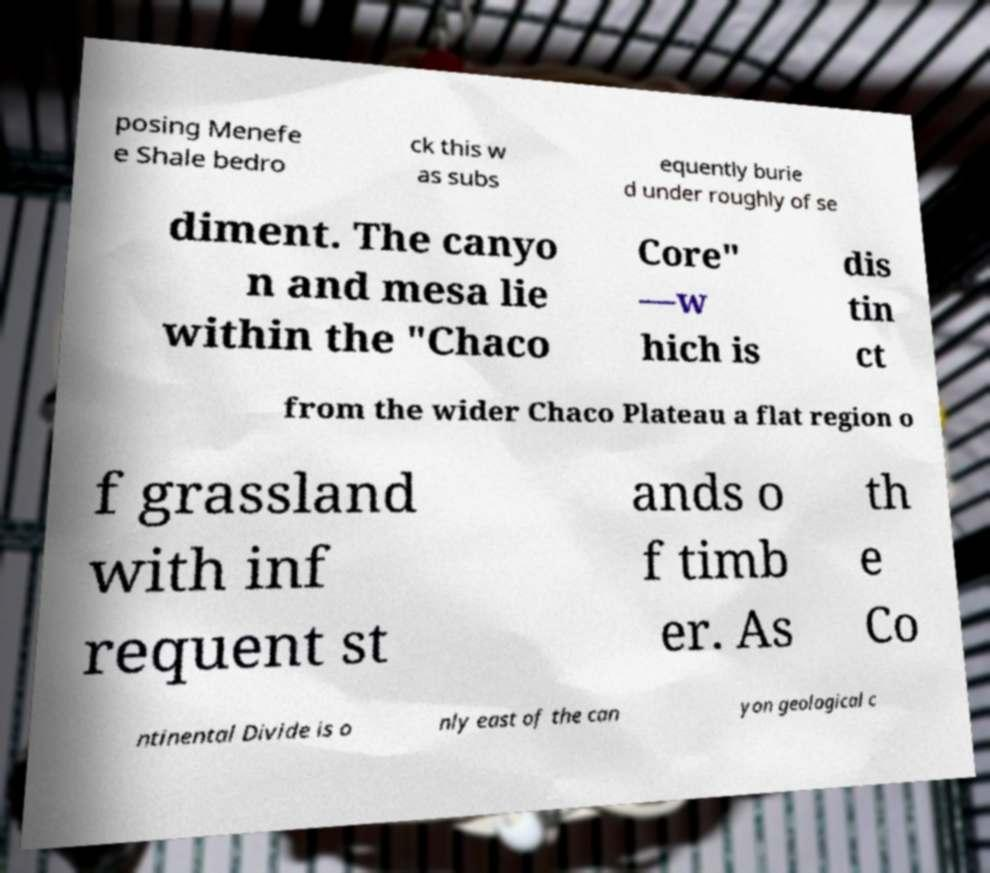Could you assist in decoding the text presented in this image and type it out clearly? posing Menefe e Shale bedro ck this w as subs equently burie d under roughly of se diment. The canyo n and mesa lie within the "Chaco Core" —w hich is dis tin ct from the wider Chaco Plateau a flat region o f grassland with inf requent st ands o f timb er. As th e Co ntinental Divide is o nly east of the can yon geological c 